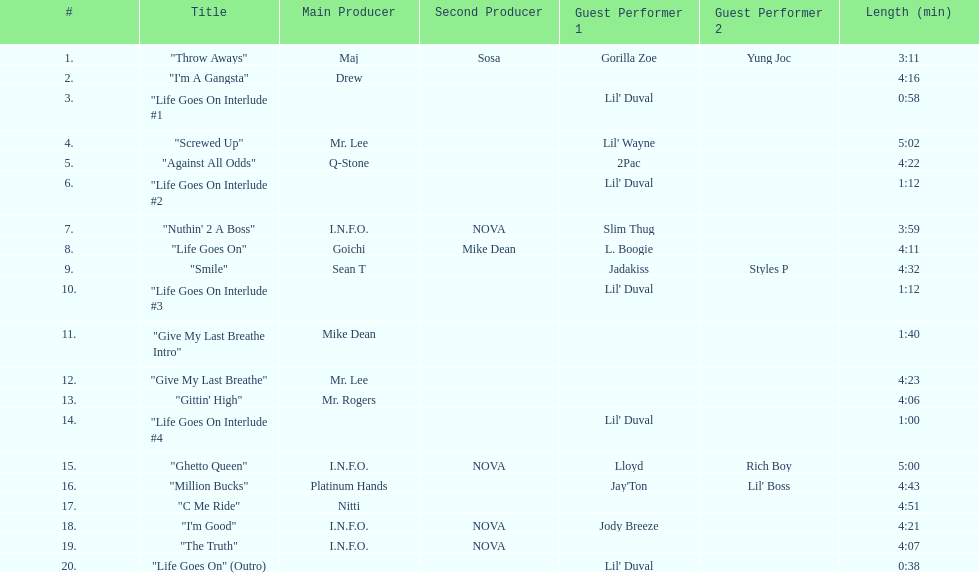Would you mind parsing the complete table? {'header': ['#', 'Title', 'Main Producer', 'Second Producer', 'Guest Performer 1', 'Guest Performer 2', 'Length (min)'], 'rows': [['1.', '"Throw Aways"', 'Maj', 'Sosa', 'Gorilla Zoe', 'Yung Joc', '3:11'], ['2.', '"I\'m A Gangsta"', 'Drew', '', '', '', '4:16'], ['3.', '"Life Goes On Interlude #1', '', '', "Lil' Duval", '', '0:58'], ['4.', '"Screwed Up"', 'Mr. Lee', '', "Lil' Wayne", '', '5:02'], ['5.', '"Against All Odds"', 'Q-Stone', '', '2Pac', '', '4:22'], ['6.', '"Life Goes On Interlude #2', '', '', "Lil' Duval", '', '1:12'], ['7.', '"Nuthin\' 2 A Boss"', 'I.N.F.O.', 'NOVA', 'Slim Thug', '', '3:59'], ['8.', '"Life Goes On"', 'Goichi', 'Mike Dean', 'L. Boogie', '', '4:11'], ['9.', '"Smile"', 'Sean T', '', 'Jadakiss', 'Styles P', '4:32'], ['10.', '"Life Goes On Interlude #3', '', '', "Lil' Duval", '', '1:12'], ['11.', '"Give My Last Breathe Intro"', 'Mike Dean', '', '', '', '1:40'], ['12.', '"Give My Last Breathe"', 'Mr. Lee', '', '', '', '4:23'], ['13.', '"Gittin\' High"', 'Mr. Rogers', '', '', '', '4:06'], ['14.', '"Life Goes On Interlude #4', '', '', "Lil' Duval", '', '1:00'], ['15.', '"Ghetto Queen"', 'I.N.F.O.', 'NOVA', 'Lloyd', 'Rich Boy', '5:00'], ['16.', '"Million Bucks"', 'Platinum Hands', '', "Jay'Ton", "Lil' Boss", '4:43'], ['17.', '"C Me Ride"', 'Nitti', '', '', '', '4:51'], ['18.', '"I\'m Good"', 'I.N.F.O.', 'NOVA', 'Jody Breeze', '', '4:21'], ['19.', '"The Truth"', 'I.N.F.O.', 'NOVA', '', '', '4:07'], ['20.', '"Life Goes On" (Outro)', '', '', "Lil' Duval", '', '0:38']]} Which producers produced the majority of songs on this record? I.N.F.O. & NOVA. 